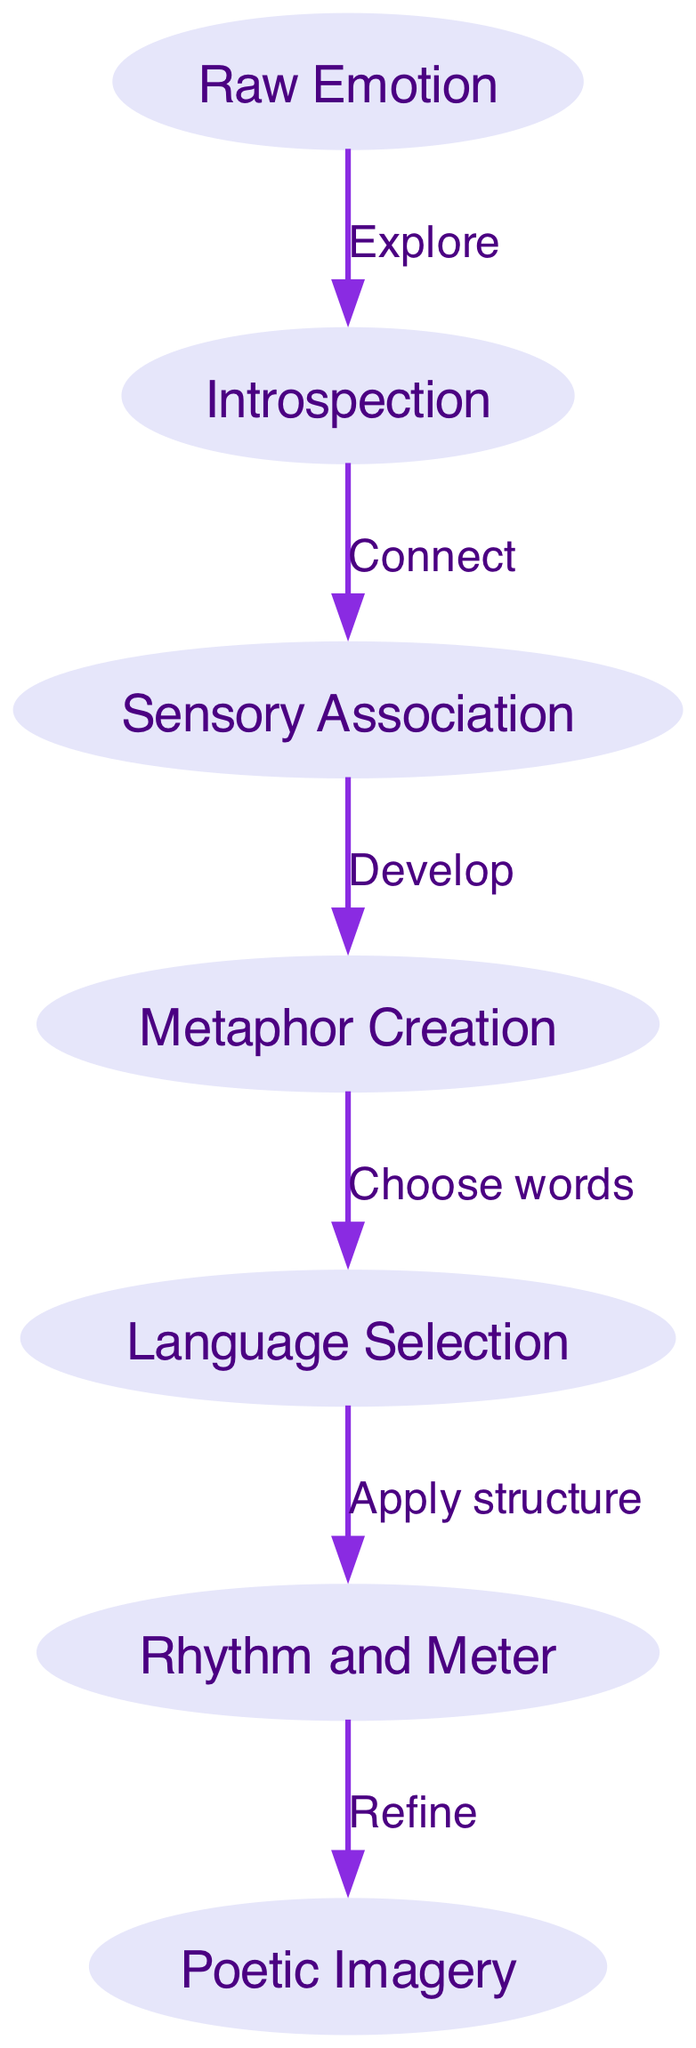What is the starting point of the process? The diagram indicates that the process begins with the node labeled "Raw Emotion." This can be identified as the first node in the flowchart.
Answer: Raw Emotion How many nodes are there in the diagram? By counting each unique node in the diagram, there are seven nodes represented, from "Raw Emotion" to "Poetic Imagery."
Answer: 7 What is the label on the edge leading from "Introspection" to "Sensory Association"? The edge connecting these two nodes is labeled "Connect," indicating the relationship or action taken between them.
Answer: Connect Which node comes after "Language Selection"? Following "Language Selection," the next node in the flowchart is "Rhythm and Meter," which directly follows it in the illustrated process.
Answer: Rhythm and Meter What action is taken between "Sensory Association" and "Metaphor Creation"? The diagram shows that the action between "Sensory Association" and "Metaphor Creation" is labeled "Develop," reflecting the process's progression.
Answer: Develop What is the final output of the entire process? The end point of the diagram is "Poetic Imagery." After all prior actions are taken, this is the final result of the transformation from raw emotions.
Answer: Poetic Imagery Which node is connected to "Rhythm and Meter" and what is the label of that edge? The node connected to "Rhythm and Meter" is "Poetic Imagery," and the edge connecting them is labeled "Refine," indicating that refinement occurs before reaching the output.
Answer: Refine What is the first action taken after exploring "Raw Emotion"? After exploring "Raw Emotion," the next action taken is "Connect," which leads to introspection, allowing for a deeper understanding of the emotion.
Answer: Connect What is the main purpose of "Metaphor Creation" in this process? The purpose of "Metaphor Creation" is to develop figurative language that enhances the poetic expression, making emotions more relatable through imagery.
Answer: Develop 